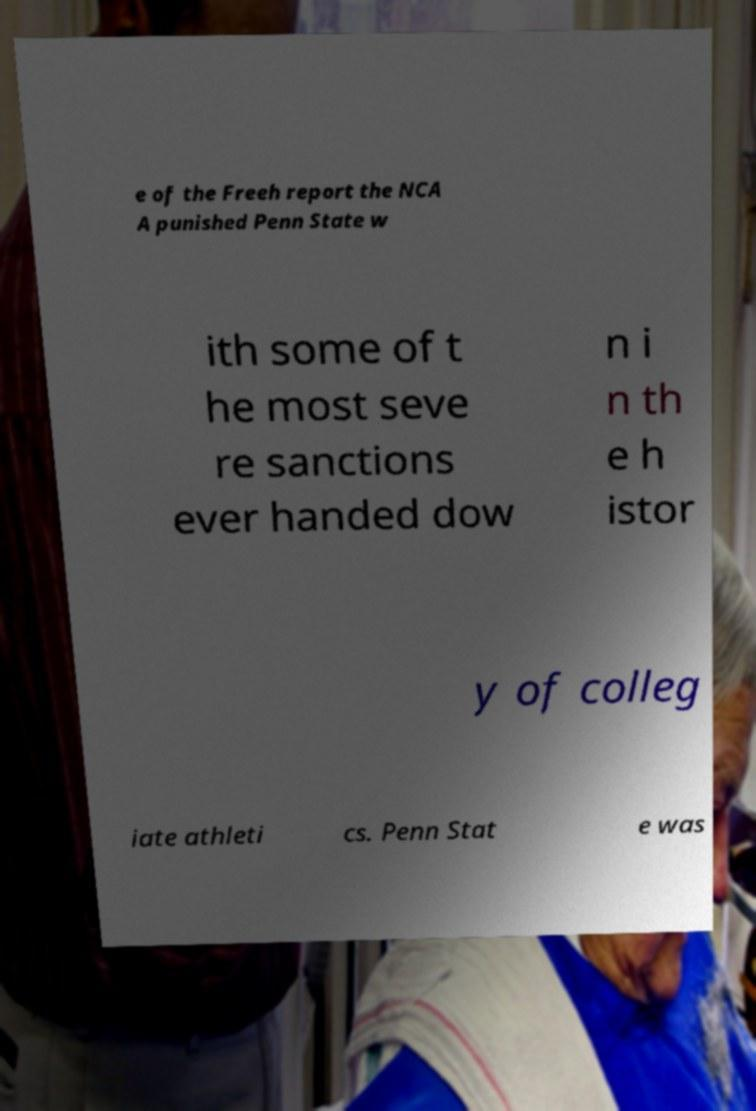There's text embedded in this image that I need extracted. Can you transcribe it verbatim? e of the Freeh report the NCA A punished Penn State w ith some of t he most seve re sanctions ever handed dow n i n th e h istor y of colleg iate athleti cs. Penn Stat e was 